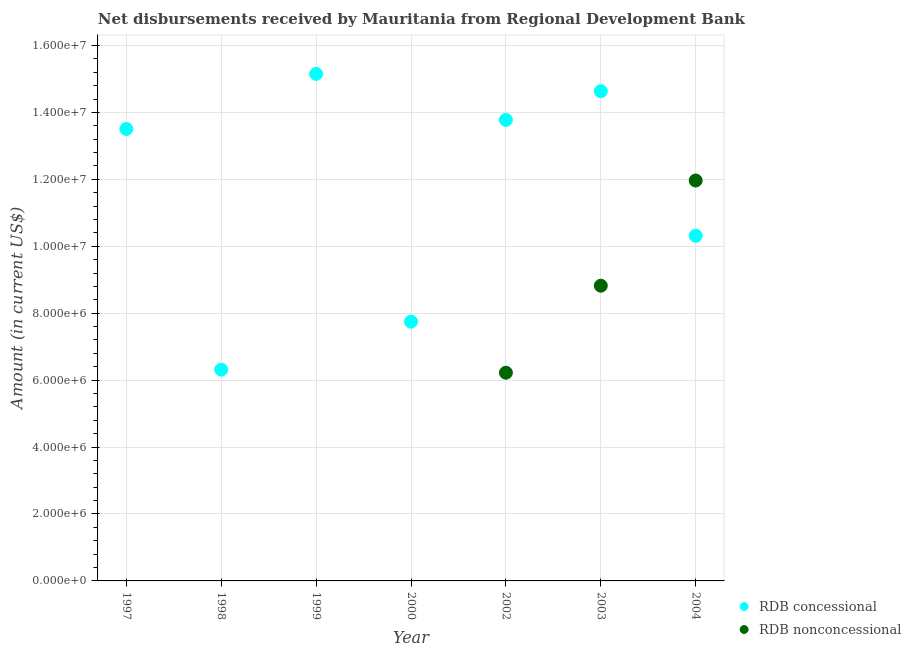How many different coloured dotlines are there?
Give a very brief answer. 2. Is the number of dotlines equal to the number of legend labels?
Keep it short and to the point. No. Across all years, what is the maximum net concessional disbursements from rdb?
Ensure brevity in your answer.  1.52e+07. Across all years, what is the minimum net concessional disbursements from rdb?
Ensure brevity in your answer.  6.31e+06. In which year was the net concessional disbursements from rdb maximum?
Make the answer very short. 1999. What is the total net non concessional disbursements from rdb in the graph?
Provide a succinct answer. 2.70e+07. What is the difference between the net non concessional disbursements from rdb in 2002 and that in 2004?
Your answer should be compact. -5.74e+06. What is the difference between the net concessional disbursements from rdb in 1997 and the net non concessional disbursements from rdb in 1999?
Provide a succinct answer. 1.35e+07. What is the average net non concessional disbursements from rdb per year?
Provide a short and direct response. 3.86e+06. In the year 2002, what is the difference between the net concessional disbursements from rdb and net non concessional disbursements from rdb?
Your answer should be compact. 7.56e+06. What is the ratio of the net concessional disbursements from rdb in 1999 to that in 2000?
Your response must be concise. 1.96. What is the difference between the highest and the second highest net non concessional disbursements from rdb?
Provide a succinct answer. 3.14e+06. What is the difference between the highest and the lowest net concessional disbursements from rdb?
Keep it short and to the point. 8.84e+06. How many dotlines are there?
Your response must be concise. 2. How many years are there in the graph?
Give a very brief answer. 7. Where does the legend appear in the graph?
Offer a terse response. Bottom right. How many legend labels are there?
Provide a succinct answer. 2. How are the legend labels stacked?
Make the answer very short. Vertical. What is the title of the graph?
Provide a succinct answer. Net disbursements received by Mauritania from Regional Development Bank. Does "Largest city" appear as one of the legend labels in the graph?
Your answer should be compact. No. What is the label or title of the Y-axis?
Provide a succinct answer. Amount (in current US$). What is the Amount (in current US$) of RDB concessional in 1997?
Offer a very short reply. 1.35e+07. What is the Amount (in current US$) in RDB concessional in 1998?
Your answer should be compact. 6.31e+06. What is the Amount (in current US$) of RDB concessional in 1999?
Provide a succinct answer. 1.52e+07. What is the Amount (in current US$) of RDB nonconcessional in 1999?
Keep it short and to the point. 0. What is the Amount (in current US$) of RDB concessional in 2000?
Your answer should be compact. 7.75e+06. What is the Amount (in current US$) in RDB concessional in 2002?
Give a very brief answer. 1.38e+07. What is the Amount (in current US$) in RDB nonconcessional in 2002?
Offer a very short reply. 6.22e+06. What is the Amount (in current US$) of RDB concessional in 2003?
Your answer should be compact. 1.46e+07. What is the Amount (in current US$) in RDB nonconcessional in 2003?
Provide a succinct answer. 8.82e+06. What is the Amount (in current US$) of RDB concessional in 2004?
Your answer should be compact. 1.03e+07. What is the Amount (in current US$) of RDB nonconcessional in 2004?
Offer a very short reply. 1.20e+07. Across all years, what is the maximum Amount (in current US$) of RDB concessional?
Provide a succinct answer. 1.52e+07. Across all years, what is the maximum Amount (in current US$) in RDB nonconcessional?
Make the answer very short. 1.20e+07. Across all years, what is the minimum Amount (in current US$) of RDB concessional?
Make the answer very short. 6.31e+06. What is the total Amount (in current US$) of RDB concessional in the graph?
Provide a short and direct response. 8.14e+07. What is the total Amount (in current US$) of RDB nonconcessional in the graph?
Your response must be concise. 2.70e+07. What is the difference between the Amount (in current US$) in RDB concessional in 1997 and that in 1998?
Ensure brevity in your answer.  7.19e+06. What is the difference between the Amount (in current US$) of RDB concessional in 1997 and that in 1999?
Make the answer very short. -1.65e+06. What is the difference between the Amount (in current US$) of RDB concessional in 1997 and that in 2000?
Your response must be concise. 5.76e+06. What is the difference between the Amount (in current US$) of RDB concessional in 1997 and that in 2002?
Provide a succinct answer. -2.70e+05. What is the difference between the Amount (in current US$) in RDB concessional in 1997 and that in 2003?
Offer a terse response. -1.13e+06. What is the difference between the Amount (in current US$) in RDB concessional in 1997 and that in 2004?
Your answer should be very brief. 3.19e+06. What is the difference between the Amount (in current US$) in RDB concessional in 1998 and that in 1999?
Provide a short and direct response. -8.84e+06. What is the difference between the Amount (in current US$) in RDB concessional in 1998 and that in 2000?
Ensure brevity in your answer.  -1.44e+06. What is the difference between the Amount (in current US$) in RDB concessional in 1998 and that in 2002?
Your answer should be very brief. -7.46e+06. What is the difference between the Amount (in current US$) in RDB concessional in 1998 and that in 2003?
Give a very brief answer. -8.32e+06. What is the difference between the Amount (in current US$) in RDB concessional in 1998 and that in 2004?
Make the answer very short. -4.00e+06. What is the difference between the Amount (in current US$) of RDB concessional in 1999 and that in 2000?
Your answer should be very brief. 7.40e+06. What is the difference between the Amount (in current US$) in RDB concessional in 1999 and that in 2002?
Your answer should be very brief. 1.38e+06. What is the difference between the Amount (in current US$) of RDB concessional in 1999 and that in 2003?
Provide a succinct answer. 5.18e+05. What is the difference between the Amount (in current US$) in RDB concessional in 1999 and that in 2004?
Keep it short and to the point. 4.84e+06. What is the difference between the Amount (in current US$) of RDB concessional in 2000 and that in 2002?
Make the answer very short. -6.03e+06. What is the difference between the Amount (in current US$) of RDB concessional in 2000 and that in 2003?
Your answer should be very brief. -6.89e+06. What is the difference between the Amount (in current US$) in RDB concessional in 2000 and that in 2004?
Provide a short and direct response. -2.57e+06. What is the difference between the Amount (in current US$) of RDB concessional in 2002 and that in 2003?
Ensure brevity in your answer.  -8.58e+05. What is the difference between the Amount (in current US$) in RDB nonconcessional in 2002 and that in 2003?
Keep it short and to the point. -2.60e+06. What is the difference between the Amount (in current US$) of RDB concessional in 2002 and that in 2004?
Offer a very short reply. 3.46e+06. What is the difference between the Amount (in current US$) in RDB nonconcessional in 2002 and that in 2004?
Provide a short and direct response. -5.74e+06. What is the difference between the Amount (in current US$) in RDB concessional in 2003 and that in 2004?
Your answer should be compact. 4.32e+06. What is the difference between the Amount (in current US$) in RDB nonconcessional in 2003 and that in 2004?
Provide a short and direct response. -3.14e+06. What is the difference between the Amount (in current US$) of RDB concessional in 1997 and the Amount (in current US$) of RDB nonconcessional in 2002?
Keep it short and to the point. 7.28e+06. What is the difference between the Amount (in current US$) of RDB concessional in 1997 and the Amount (in current US$) of RDB nonconcessional in 2003?
Keep it short and to the point. 4.68e+06. What is the difference between the Amount (in current US$) of RDB concessional in 1997 and the Amount (in current US$) of RDB nonconcessional in 2004?
Keep it short and to the point. 1.54e+06. What is the difference between the Amount (in current US$) of RDB concessional in 1998 and the Amount (in current US$) of RDB nonconcessional in 2002?
Offer a very short reply. 9.20e+04. What is the difference between the Amount (in current US$) in RDB concessional in 1998 and the Amount (in current US$) in RDB nonconcessional in 2003?
Offer a very short reply. -2.51e+06. What is the difference between the Amount (in current US$) in RDB concessional in 1998 and the Amount (in current US$) in RDB nonconcessional in 2004?
Ensure brevity in your answer.  -5.65e+06. What is the difference between the Amount (in current US$) in RDB concessional in 1999 and the Amount (in current US$) in RDB nonconcessional in 2002?
Offer a terse response. 8.93e+06. What is the difference between the Amount (in current US$) in RDB concessional in 1999 and the Amount (in current US$) in RDB nonconcessional in 2003?
Provide a short and direct response. 6.33e+06. What is the difference between the Amount (in current US$) in RDB concessional in 1999 and the Amount (in current US$) in RDB nonconcessional in 2004?
Your answer should be compact. 3.19e+06. What is the difference between the Amount (in current US$) of RDB concessional in 2000 and the Amount (in current US$) of RDB nonconcessional in 2002?
Your response must be concise. 1.53e+06. What is the difference between the Amount (in current US$) in RDB concessional in 2000 and the Amount (in current US$) in RDB nonconcessional in 2003?
Make the answer very short. -1.07e+06. What is the difference between the Amount (in current US$) in RDB concessional in 2000 and the Amount (in current US$) in RDB nonconcessional in 2004?
Provide a succinct answer. -4.22e+06. What is the difference between the Amount (in current US$) in RDB concessional in 2002 and the Amount (in current US$) in RDB nonconcessional in 2003?
Offer a terse response. 4.96e+06. What is the difference between the Amount (in current US$) of RDB concessional in 2002 and the Amount (in current US$) of RDB nonconcessional in 2004?
Ensure brevity in your answer.  1.81e+06. What is the difference between the Amount (in current US$) of RDB concessional in 2003 and the Amount (in current US$) of RDB nonconcessional in 2004?
Ensure brevity in your answer.  2.67e+06. What is the average Amount (in current US$) in RDB concessional per year?
Offer a terse response. 1.16e+07. What is the average Amount (in current US$) of RDB nonconcessional per year?
Give a very brief answer. 3.86e+06. In the year 2002, what is the difference between the Amount (in current US$) in RDB concessional and Amount (in current US$) in RDB nonconcessional?
Offer a terse response. 7.56e+06. In the year 2003, what is the difference between the Amount (in current US$) in RDB concessional and Amount (in current US$) in RDB nonconcessional?
Make the answer very short. 5.81e+06. In the year 2004, what is the difference between the Amount (in current US$) of RDB concessional and Amount (in current US$) of RDB nonconcessional?
Your response must be concise. -1.65e+06. What is the ratio of the Amount (in current US$) of RDB concessional in 1997 to that in 1998?
Offer a terse response. 2.14. What is the ratio of the Amount (in current US$) in RDB concessional in 1997 to that in 1999?
Your answer should be very brief. 0.89. What is the ratio of the Amount (in current US$) in RDB concessional in 1997 to that in 2000?
Keep it short and to the point. 1.74. What is the ratio of the Amount (in current US$) in RDB concessional in 1997 to that in 2002?
Give a very brief answer. 0.98. What is the ratio of the Amount (in current US$) of RDB concessional in 1997 to that in 2003?
Make the answer very short. 0.92. What is the ratio of the Amount (in current US$) of RDB concessional in 1997 to that in 2004?
Your answer should be very brief. 1.31. What is the ratio of the Amount (in current US$) in RDB concessional in 1998 to that in 1999?
Offer a terse response. 0.42. What is the ratio of the Amount (in current US$) in RDB concessional in 1998 to that in 2000?
Your response must be concise. 0.81. What is the ratio of the Amount (in current US$) in RDB concessional in 1998 to that in 2002?
Ensure brevity in your answer.  0.46. What is the ratio of the Amount (in current US$) in RDB concessional in 1998 to that in 2003?
Your answer should be compact. 0.43. What is the ratio of the Amount (in current US$) of RDB concessional in 1998 to that in 2004?
Give a very brief answer. 0.61. What is the ratio of the Amount (in current US$) in RDB concessional in 1999 to that in 2000?
Keep it short and to the point. 1.96. What is the ratio of the Amount (in current US$) of RDB concessional in 1999 to that in 2002?
Provide a succinct answer. 1.1. What is the ratio of the Amount (in current US$) of RDB concessional in 1999 to that in 2003?
Provide a short and direct response. 1.04. What is the ratio of the Amount (in current US$) in RDB concessional in 1999 to that in 2004?
Offer a very short reply. 1.47. What is the ratio of the Amount (in current US$) in RDB concessional in 2000 to that in 2002?
Keep it short and to the point. 0.56. What is the ratio of the Amount (in current US$) of RDB concessional in 2000 to that in 2003?
Your answer should be compact. 0.53. What is the ratio of the Amount (in current US$) of RDB concessional in 2000 to that in 2004?
Your response must be concise. 0.75. What is the ratio of the Amount (in current US$) of RDB concessional in 2002 to that in 2003?
Your response must be concise. 0.94. What is the ratio of the Amount (in current US$) of RDB nonconcessional in 2002 to that in 2003?
Provide a succinct answer. 0.71. What is the ratio of the Amount (in current US$) in RDB concessional in 2002 to that in 2004?
Your answer should be compact. 1.34. What is the ratio of the Amount (in current US$) in RDB nonconcessional in 2002 to that in 2004?
Your response must be concise. 0.52. What is the ratio of the Amount (in current US$) in RDB concessional in 2003 to that in 2004?
Give a very brief answer. 1.42. What is the ratio of the Amount (in current US$) in RDB nonconcessional in 2003 to that in 2004?
Provide a short and direct response. 0.74. What is the difference between the highest and the second highest Amount (in current US$) in RDB concessional?
Offer a terse response. 5.18e+05. What is the difference between the highest and the second highest Amount (in current US$) in RDB nonconcessional?
Provide a short and direct response. 3.14e+06. What is the difference between the highest and the lowest Amount (in current US$) of RDB concessional?
Your response must be concise. 8.84e+06. What is the difference between the highest and the lowest Amount (in current US$) of RDB nonconcessional?
Your answer should be compact. 1.20e+07. 